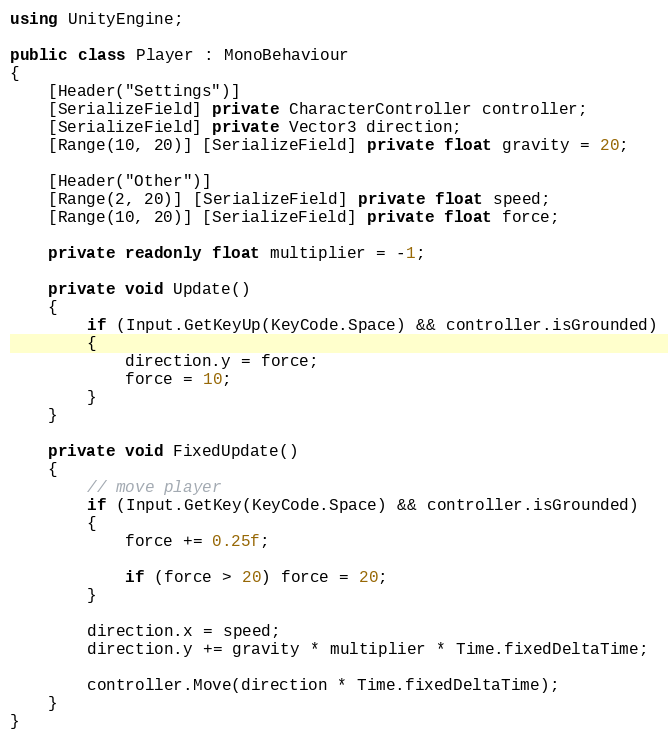Convert code to text. <code><loc_0><loc_0><loc_500><loc_500><_C#_>using UnityEngine;

public class Player : MonoBehaviour
{
    [Header("Settings")]
    [SerializeField] private CharacterController controller;
    [SerializeField] private Vector3 direction;
    [Range(10, 20)] [SerializeField] private float gravity = 20;

    [Header("Other")]
    [Range(2, 20)] [SerializeField] private float speed;
    [Range(10, 20)] [SerializeField] private float force;

    private readonly float multiplier = -1;

    private void Update()
    {
        if (Input.GetKeyUp(KeyCode.Space) && controller.isGrounded)
        {
            direction.y = force;
            force = 10;
        }
    }

    private void FixedUpdate()
    {
        // move player
        if (Input.GetKey(KeyCode.Space) && controller.isGrounded)
        {
            force += 0.25f;

            if (force > 20) force = 20;
        }

        direction.x = speed;
        direction.y += gravity * multiplier * Time.fixedDeltaTime;

        controller.Move(direction * Time.fixedDeltaTime);
    }
}</code> 